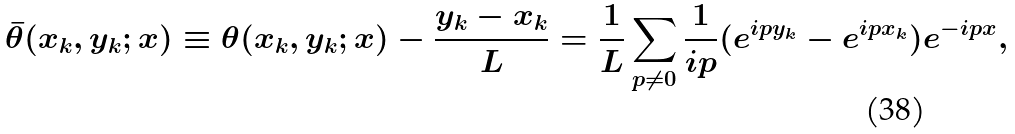<formula> <loc_0><loc_0><loc_500><loc_500>\bar { \theta } ( x _ { k } , y _ { k } ; x ) \equiv \theta ( x _ { k } , y _ { k } ; x ) - \frac { y _ { k } - x _ { k } } { L } = \frac { 1 } { L } \sum _ { p \ne 0 } \frac { 1 } { i p } ( e ^ { i p y _ { k } } - e ^ { i p x _ { k } } ) e ^ { - i p x } ,</formula> 